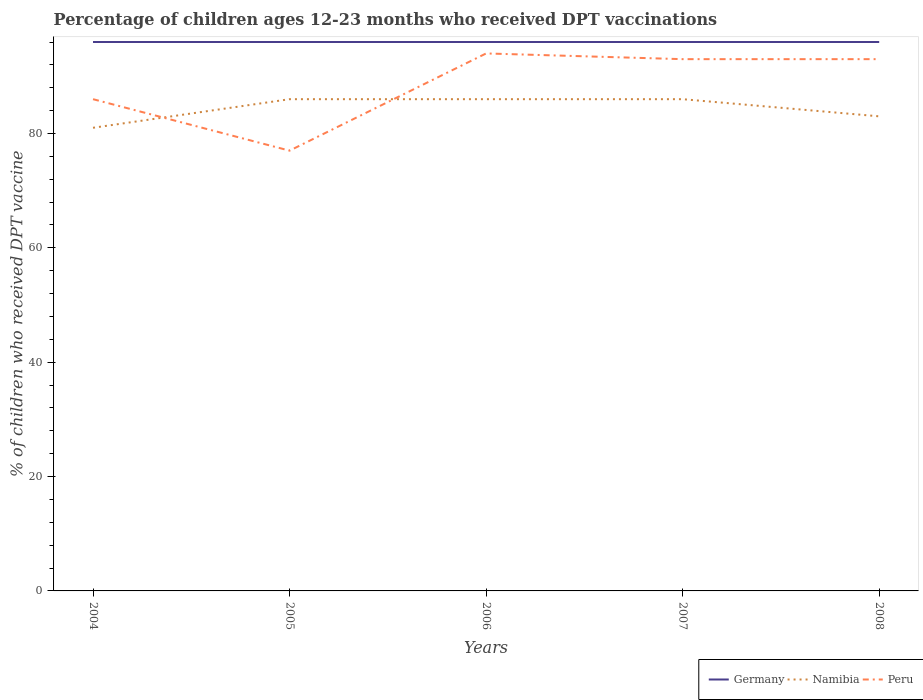How many different coloured lines are there?
Your answer should be compact. 3. Is the number of lines equal to the number of legend labels?
Provide a succinct answer. Yes. Across all years, what is the maximum percentage of children who received DPT vaccination in Peru?
Your answer should be compact. 77. In which year was the percentage of children who received DPT vaccination in Namibia maximum?
Offer a very short reply. 2004. What is the difference between the highest and the second highest percentage of children who received DPT vaccination in Namibia?
Offer a very short reply. 5. What is the difference between the highest and the lowest percentage of children who received DPT vaccination in Namibia?
Your answer should be compact. 3. What is the difference between two consecutive major ticks on the Y-axis?
Your response must be concise. 20. Does the graph contain any zero values?
Your answer should be compact. No. Where does the legend appear in the graph?
Ensure brevity in your answer.  Bottom right. How many legend labels are there?
Your response must be concise. 3. How are the legend labels stacked?
Offer a very short reply. Horizontal. What is the title of the graph?
Your answer should be very brief. Percentage of children ages 12-23 months who received DPT vaccinations. Does "Swaziland" appear as one of the legend labels in the graph?
Provide a short and direct response. No. What is the label or title of the X-axis?
Offer a terse response. Years. What is the label or title of the Y-axis?
Ensure brevity in your answer.  % of children who received DPT vaccine. What is the % of children who received DPT vaccine of Germany in 2004?
Ensure brevity in your answer.  96. What is the % of children who received DPT vaccine of Peru in 2004?
Your answer should be compact. 86. What is the % of children who received DPT vaccine in Germany in 2005?
Your response must be concise. 96. What is the % of children who received DPT vaccine in Germany in 2006?
Keep it short and to the point. 96. What is the % of children who received DPT vaccine in Namibia in 2006?
Make the answer very short. 86. What is the % of children who received DPT vaccine in Peru in 2006?
Your answer should be compact. 94. What is the % of children who received DPT vaccine of Germany in 2007?
Make the answer very short. 96. What is the % of children who received DPT vaccine in Namibia in 2007?
Your response must be concise. 86. What is the % of children who received DPT vaccine in Peru in 2007?
Your response must be concise. 93. What is the % of children who received DPT vaccine of Germany in 2008?
Your answer should be very brief. 96. What is the % of children who received DPT vaccine of Peru in 2008?
Your answer should be very brief. 93. Across all years, what is the maximum % of children who received DPT vaccine in Germany?
Provide a short and direct response. 96. Across all years, what is the maximum % of children who received DPT vaccine in Namibia?
Provide a short and direct response. 86. Across all years, what is the maximum % of children who received DPT vaccine of Peru?
Make the answer very short. 94. Across all years, what is the minimum % of children who received DPT vaccine of Germany?
Your answer should be very brief. 96. What is the total % of children who received DPT vaccine of Germany in the graph?
Give a very brief answer. 480. What is the total % of children who received DPT vaccine of Namibia in the graph?
Offer a very short reply. 422. What is the total % of children who received DPT vaccine in Peru in the graph?
Keep it short and to the point. 443. What is the difference between the % of children who received DPT vaccine in Germany in 2004 and that in 2005?
Provide a short and direct response. 0. What is the difference between the % of children who received DPT vaccine in Namibia in 2004 and that in 2005?
Give a very brief answer. -5. What is the difference between the % of children who received DPT vaccine of Peru in 2004 and that in 2005?
Offer a terse response. 9. What is the difference between the % of children who received DPT vaccine in Germany in 2004 and that in 2006?
Your response must be concise. 0. What is the difference between the % of children who received DPT vaccine in Namibia in 2004 and that in 2006?
Your answer should be very brief. -5. What is the difference between the % of children who received DPT vaccine of Peru in 2004 and that in 2006?
Your answer should be very brief. -8. What is the difference between the % of children who received DPT vaccine in Germany in 2004 and that in 2008?
Give a very brief answer. 0. What is the difference between the % of children who received DPT vaccine in Peru in 2004 and that in 2008?
Your answer should be compact. -7. What is the difference between the % of children who received DPT vaccine in Germany in 2005 and that in 2006?
Offer a very short reply. 0. What is the difference between the % of children who received DPT vaccine in Namibia in 2005 and that in 2006?
Your answer should be compact. 0. What is the difference between the % of children who received DPT vaccine of Namibia in 2005 and that in 2007?
Ensure brevity in your answer.  0. What is the difference between the % of children who received DPT vaccine of Peru in 2006 and that in 2007?
Provide a succinct answer. 1. What is the difference between the % of children who received DPT vaccine of Germany in 2006 and that in 2008?
Your answer should be very brief. 0. What is the difference between the % of children who received DPT vaccine in Namibia in 2006 and that in 2008?
Give a very brief answer. 3. What is the difference between the % of children who received DPT vaccine in Peru in 2006 and that in 2008?
Provide a succinct answer. 1. What is the difference between the % of children who received DPT vaccine of Germany in 2007 and that in 2008?
Keep it short and to the point. 0. What is the difference between the % of children who received DPT vaccine in Peru in 2007 and that in 2008?
Keep it short and to the point. 0. What is the difference between the % of children who received DPT vaccine of Germany in 2004 and the % of children who received DPT vaccine of Namibia in 2005?
Make the answer very short. 10. What is the difference between the % of children who received DPT vaccine in Namibia in 2004 and the % of children who received DPT vaccine in Peru in 2005?
Provide a succinct answer. 4. What is the difference between the % of children who received DPT vaccine of Germany in 2004 and the % of children who received DPT vaccine of Peru in 2007?
Provide a short and direct response. 3. What is the difference between the % of children who received DPT vaccine of Germany in 2004 and the % of children who received DPT vaccine of Peru in 2008?
Ensure brevity in your answer.  3. What is the difference between the % of children who received DPT vaccine in Germany in 2005 and the % of children who received DPT vaccine in Namibia in 2006?
Offer a very short reply. 10. What is the difference between the % of children who received DPT vaccine in Germany in 2005 and the % of children who received DPT vaccine in Peru in 2006?
Provide a succinct answer. 2. What is the difference between the % of children who received DPT vaccine in Namibia in 2005 and the % of children who received DPT vaccine in Peru in 2006?
Offer a terse response. -8. What is the difference between the % of children who received DPT vaccine of Germany in 2005 and the % of children who received DPT vaccine of Peru in 2007?
Provide a short and direct response. 3. What is the difference between the % of children who received DPT vaccine in Namibia in 2005 and the % of children who received DPT vaccine in Peru in 2007?
Ensure brevity in your answer.  -7. What is the difference between the % of children who received DPT vaccine of Germany in 2005 and the % of children who received DPT vaccine of Namibia in 2008?
Give a very brief answer. 13. What is the difference between the % of children who received DPT vaccine in Germany in 2006 and the % of children who received DPT vaccine in Peru in 2007?
Keep it short and to the point. 3. What is the difference between the % of children who received DPT vaccine in Namibia in 2006 and the % of children who received DPT vaccine in Peru in 2007?
Your answer should be compact. -7. What is the difference between the % of children who received DPT vaccine in Germany in 2006 and the % of children who received DPT vaccine in Peru in 2008?
Your response must be concise. 3. What is the difference between the % of children who received DPT vaccine in Namibia in 2006 and the % of children who received DPT vaccine in Peru in 2008?
Provide a succinct answer. -7. What is the difference between the % of children who received DPT vaccine of Germany in 2007 and the % of children who received DPT vaccine of Namibia in 2008?
Offer a very short reply. 13. What is the difference between the % of children who received DPT vaccine of Namibia in 2007 and the % of children who received DPT vaccine of Peru in 2008?
Your response must be concise. -7. What is the average % of children who received DPT vaccine in Germany per year?
Make the answer very short. 96. What is the average % of children who received DPT vaccine of Namibia per year?
Ensure brevity in your answer.  84.4. What is the average % of children who received DPT vaccine of Peru per year?
Your answer should be very brief. 88.6. In the year 2004, what is the difference between the % of children who received DPT vaccine in Germany and % of children who received DPT vaccine in Namibia?
Offer a very short reply. 15. In the year 2005, what is the difference between the % of children who received DPT vaccine of Germany and % of children who received DPT vaccine of Namibia?
Your response must be concise. 10. In the year 2005, what is the difference between the % of children who received DPT vaccine in Namibia and % of children who received DPT vaccine in Peru?
Offer a very short reply. 9. In the year 2006, what is the difference between the % of children who received DPT vaccine of Germany and % of children who received DPT vaccine of Namibia?
Your response must be concise. 10. In the year 2006, what is the difference between the % of children who received DPT vaccine of Namibia and % of children who received DPT vaccine of Peru?
Make the answer very short. -8. In the year 2007, what is the difference between the % of children who received DPT vaccine of Namibia and % of children who received DPT vaccine of Peru?
Give a very brief answer. -7. In the year 2008, what is the difference between the % of children who received DPT vaccine of Namibia and % of children who received DPT vaccine of Peru?
Keep it short and to the point. -10. What is the ratio of the % of children who received DPT vaccine of Germany in 2004 to that in 2005?
Offer a terse response. 1. What is the ratio of the % of children who received DPT vaccine of Namibia in 2004 to that in 2005?
Provide a short and direct response. 0.94. What is the ratio of the % of children who received DPT vaccine of Peru in 2004 to that in 2005?
Offer a very short reply. 1.12. What is the ratio of the % of children who received DPT vaccine in Germany in 2004 to that in 2006?
Make the answer very short. 1. What is the ratio of the % of children who received DPT vaccine in Namibia in 2004 to that in 2006?
Offer a very short reply. 0.94. What is the ratio of the % of children who received DPT vaccine of Peru in 2004 to that in 2006?
Your response must be concise. 0.91. What is the ratio of the % of children who received DPT vaccine of Namibia in 2004 to that in 2007?
Make the answer very short. 0.94. What is the ratio of the % of children who received DPT vaccine in Peru in 2004 to that in 2007?
Provide a short and direct response. 0.92. What is the ratio of the % of children who received DPT vaccine of Namibia in 2004 to that in 2008?
Offer a very short reply. 0.98. What is the ratio of the % of children who received DPT vaccine in Peru in 2004 to that in 2008?
Offer a very short reply. 0.92. What is the ratio of the % of children who received DPT vaccine in Germany in 2005 to that in 2006?
Your response must be concise. 1. What is the ratio of the % of children who received DPT vaccine in Namibia in 2005 to that in 2006?
Keep it short and to the point. 1. What is the ratio of the % of children who received DPT vaccine of Peru in 2005 to that in 2006?
Ensure brevity in your answer.  0.82. What is the ratio of the % of children who received DPT vaccine of Namibia in 2005 to that in 2007?
Your answer should be very brief. 1. What is the ratio of the % of children who received DPT vaccine in Peru in 2005 to that in 2007?
Your answer should be very brief. 0.83. What is the ratio of the % of children who received DPT vaccine in Germany in 2005 to that in 2008?
Keep it short and to the point. 1. What is the ratio of the % of children who received DPT vaccine of Namibia in 2005 to that in 2008?
Provide a succinct answer. 1.04. What is the ratio of the % of children who received DPT vaccine of Peru in 2005 to that in 2008?
Give a very brief answer. 0.83. What is the ratio of the % of children who received DPT vaccine in Namibia in 2006 to that in 2007?
Your answer should be very brief. 1. What is the ratio of the % of children who received DPT vaccine in Peru in 2006 to that in 2007?
Your answer should be compact. 1.01. What is the ratio of the % of children who received DPT vaccine in Namibia in 2006 to that in 2008?
Keep it short and to the point. 1.04. What is the ratio of the % of children who received DPT vaccine of Peru in 2006 to that in 2008?
Your answer should be compact. 1.01. What is the ratio of the % of children who received DPT vaccine of Germany in 2007 to that in 2008?
Provide a short and direct response. 1. What is the ratio of the % of children who received DPT vaccine of Namibia in 2007 to that in 2008?
Keep it short and to the point. 1.04. What is the difference between the highest and the second highest % of children who received DPT vaccine of Germany?
Provide a short and direct response. 0. What is the difference between the highest and the lowest % of children who received DPT vaccine of Germany?
Offer a very short reply. 0. What is the difference between the highest and the lowest % of children who received DPT vaccine of Namibia?
Ensure brevity in your answer.  5. What is the difference between the highest and the lowest % of children who received DPT vaccine of Peru?
Offer a very short reply. 17. 